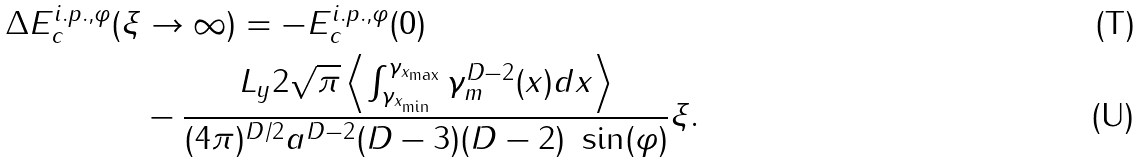<formula> <loc_0><loc_0><loc_500><loc_500>\Delta E _ { c } ^ { i . p . , \varphi } ( \xi & \rightarrow \infty ) = - E _ { c } ^ { i . p . , \varphi } ( 0 ) \\ & - \frac { L _ { y } 2 \sqrt { \pi } \left \langle \int _ { \gamma _ { x _ { \min } } } ^ { \gamma _ { x _ { \max } } } \gamma _ { m } ^ { D - 2 } ( x ) d x \right \rangle } { ( 4 \pi ) ^ { D / 2 } a ^ { D - 2 } ( D - 3 ) ( D - 2 ) \ \sin ( \varphi ) } \xi .</formula> 